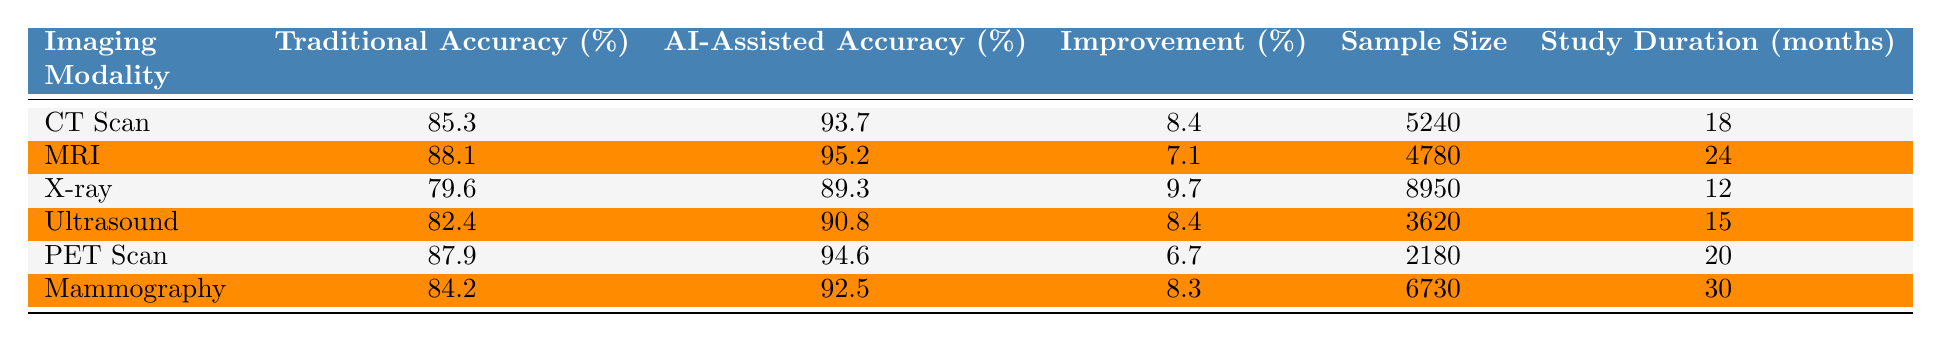What is the traditional diagnostic accuracy for X-ray? The table shows that the traditional diagnostic accuracy for X-ray is 79.6%.
Answer: 79.6% Which imaging modality has the highest AI-assisted diagnostic accuracy? By comparing the AI-assisted diagnostic accuracies, MRI has the highest at 95.2%.
Answer: MRI What is the sample size for the CT Scan study? The table indicates that the sample size for the CT Scan study is 5240.
Answer: 5240 What is the improvement percentage for Ultrasound? According to the table, the improvement percentage for Ultrasound is 8.4%.
Answer: 8.4% Which imaging modality showed the least improvement in diagnostic accuracy? The least improvement percentage in the table is for PET Scan at 6.7%.
Answer: PET Scan What is the average traditional diagnostic accuracy across all modalities? The traditional diagnostic accuracies are 85.3, 88.1, 79.6, 82.4, 87.9, and 84.2. Summing these yields 507.5, and dividing by 6 gives an average of approximately 84.58%.
Answer: 84.6% Is the AI-assisted diagnostic accuracy for Mammography higher than 90%? Yes, the AI-assisted diagnostic accuracy for Mammography is 92.5%, which is indeed higher than 90%.
Answer: Yes What is the difference in traditional diagnostic accuracy between X-ray and CT Scan? The traditional accuracy for X-ray is 79.6% and for CT Scan is 85.3%. The difference is 85.3 - 79.6 = 5.7%.
Answer: 5.7% How many months was the study duration for the MRI? The study duration for MRI is stated in the table as 24 months.
Answer: 24 months Which imaging modality has the smallest sample size? The smallest sample size listed in the table is for the PET Scan, with a count of 2180.
Answer: PET Scan 